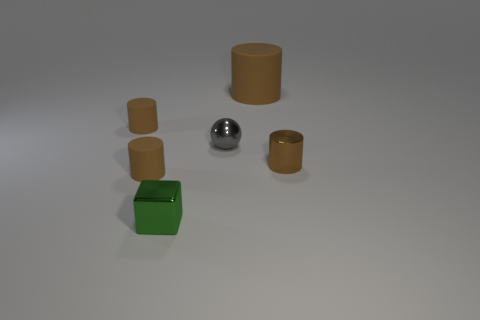What color is the metallic object that is the same shape as the big brown matte thing?
Offer a very short reply. Brown. Are there the same number of small things on the right side of the tiny brown metal cylinder and small gray balls?
Make the answer very short. No. How many cubes are either tiny objects or large things?
Your answer should be compact. 1. What color is the tiny cylinder that is made of the same material as the sphere?
Offer a terse response. Brown. Is the small gray sphere made of the same material as the small cylinder that is on the right side of the green cube?
Keep it short and to the point. Yes. What number of things are either green objects or small brown metallic cylinders?
Keep it short and to the point. 2. What is the material of the large object that is the same color as the small shiny cylinder?
Ensure brevity in your answer.  Rubber. Are there any small purple matte things of the same shape as the small green shiny object?
Provide a short and direct response. No. What number of brown cylinders are right of the gray ball?
Offer a terse response. 2. What material is the small brown cylinder behind the tiny brown object on the right side of the small green cube made of?
Give a very brief answer. Rubber. 